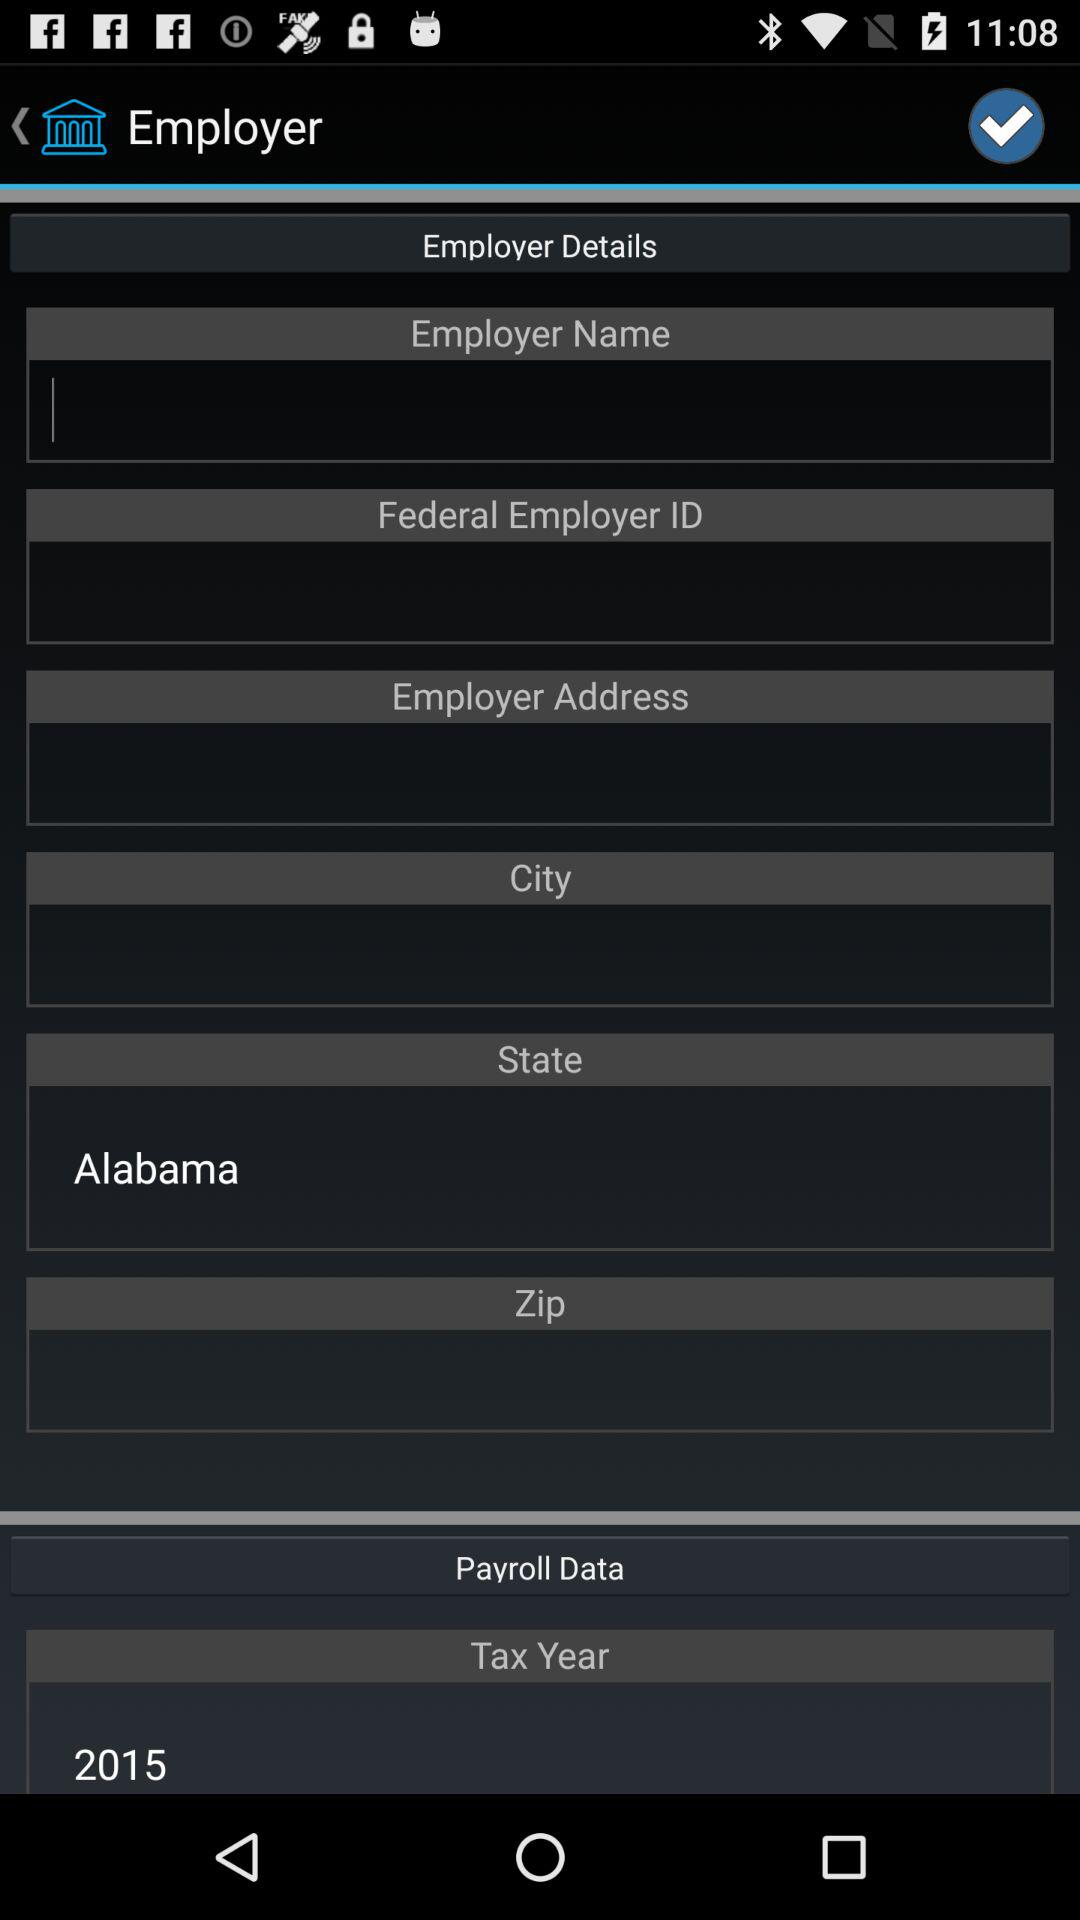What is the tax year for this employer?
Answer the question using a single word or phrase. 2015 